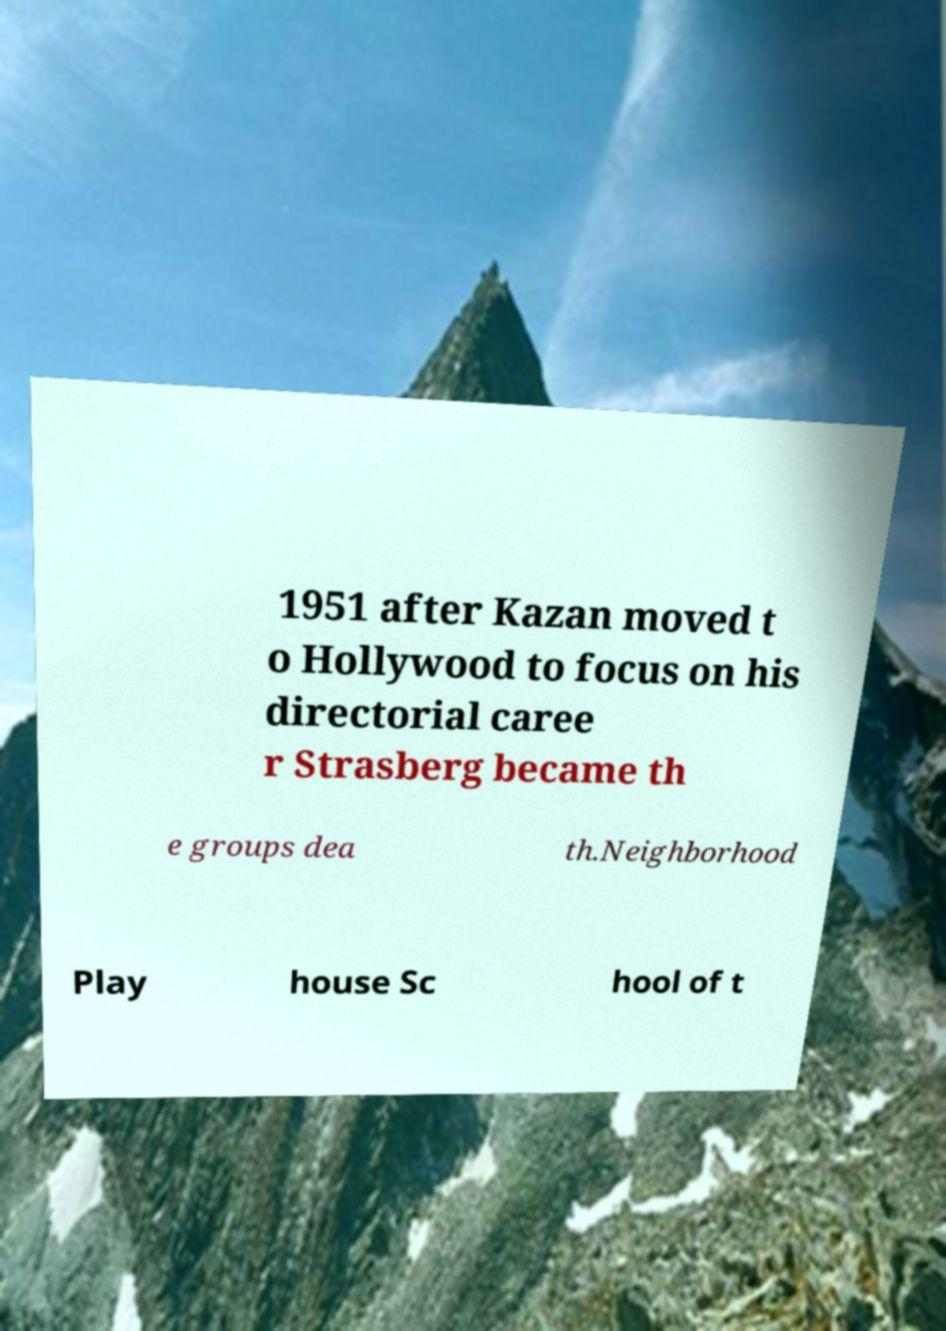Can you read and provide the text displayed in the image?This photo seems to have some interesting text. Can you extract and type it out for me? 1951 after Kazan moved t o Hollywood to focus on his directorial caree r Strasberg became th e groups dea th.Neighborhood Play house Sc hool of t 